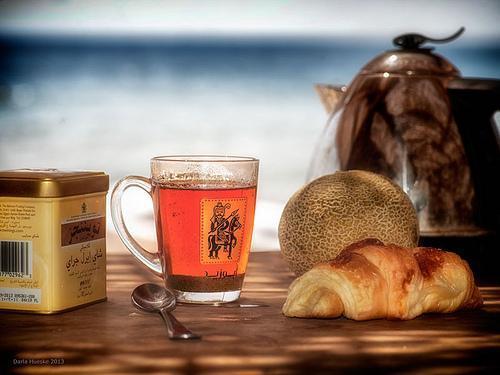How many cups on the table?
Give a very brief answer. 1. 